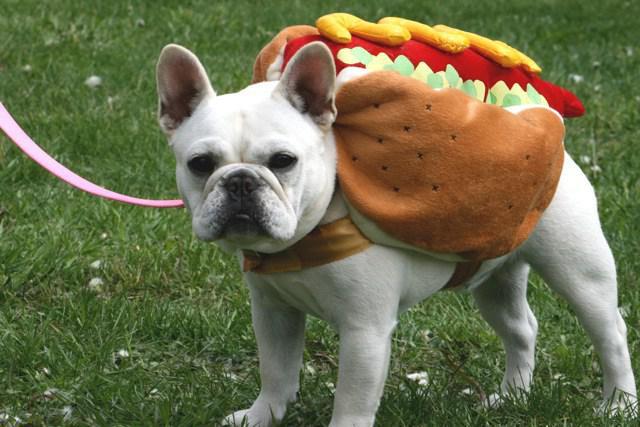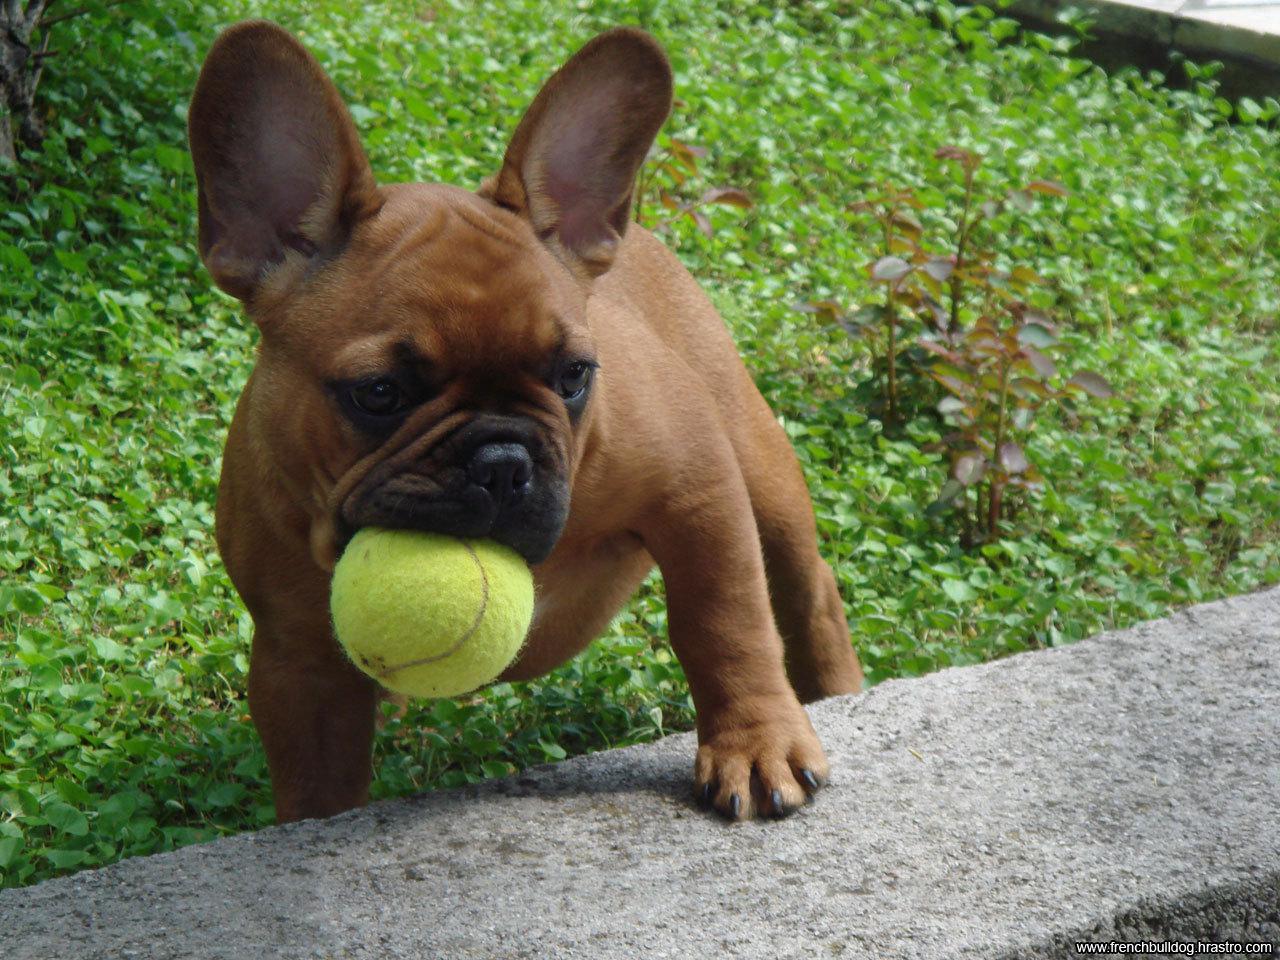The first image is the image on the left, the second image is the image on the right. Analyze the images presented: Is the assertion "There are two dogs in the right image." valid? Answer yes or no. No. The first image is the image on the left, the second image is the image on the right. For the images displayed, is the sentence "One of the images shows a bulldog on a leash with its body facing leftward." factually correct? Answer yes or no. Yes. 